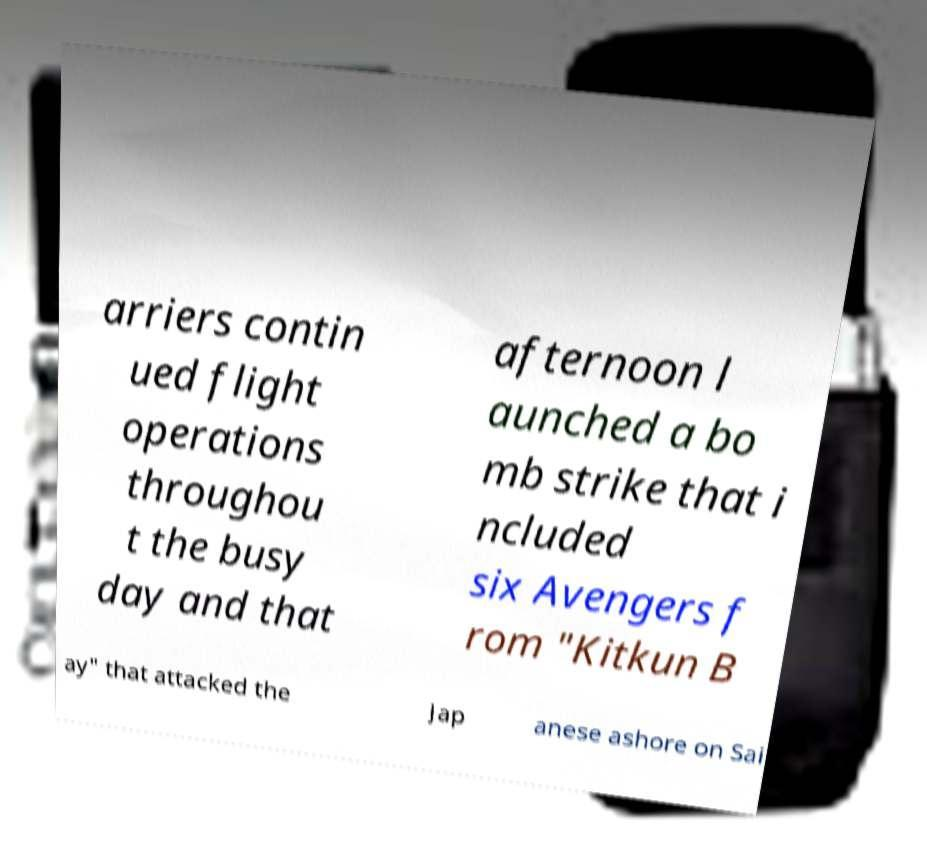I need the written content from this picture converted into text. Can you do that? arriers contin ued flight operations throughou t the busy day and that afternoon l aunched a bo mb strike that i ncluded six Avengers f rom "Kitkun B ay" that attacked the Jap anese ashore on Sai 